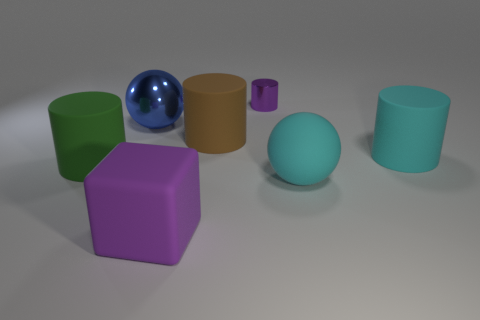How many other matte blocks have the same size as the rubber block?
Your answer should be compact. 0. What is the material of the cylinder that is the same color as the block?
Offer a terse response. Metal. Is the shape of the metallic object to the left of the big purple block the same as  the purple metal thing?
Keep it short and to the point. No. Are there fewer purple objects that are behind the tiny purple object than purple cylinders?
Give a very brief answer. Yes. Are there any big rubber cubes that have the same color as the metal cylinder?
Provide a succinct answer. Yes. There is a big brown rubber object; is it the same shape as the cyan matte thing in front of the big cyan cylinder?
Your response must be concise. No. Are there any large balls that have the same material as the brown cylinder?
Offer a terse response. Yes. There is a metallic object on the right side of the purple object in front of the large green matte cylinder; are there any large things that are behind it?
Ensure brevity in your answer.  No. How many other things are the same shape as the large green matte thing?
Make the answer very short. 3. The big matte object on the left side of the ball that is behind the large cyan object that is behind the big cyan rubber ball is what color?
Offer a very short reply. Green. 